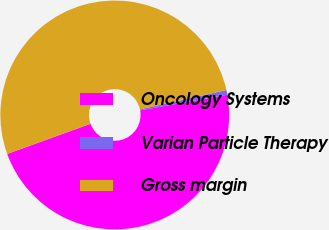Convert chart to OTSL. <chart><loc_0><loc_0><loc_500><loc_500><pie_chart><fcel>Oncology Systems<fcel>Varian Particle Therapy<fcel>Gross margin<nl><fcel>47.3%<fcel>0.66%<fcel>52.03%<nl></chart> 